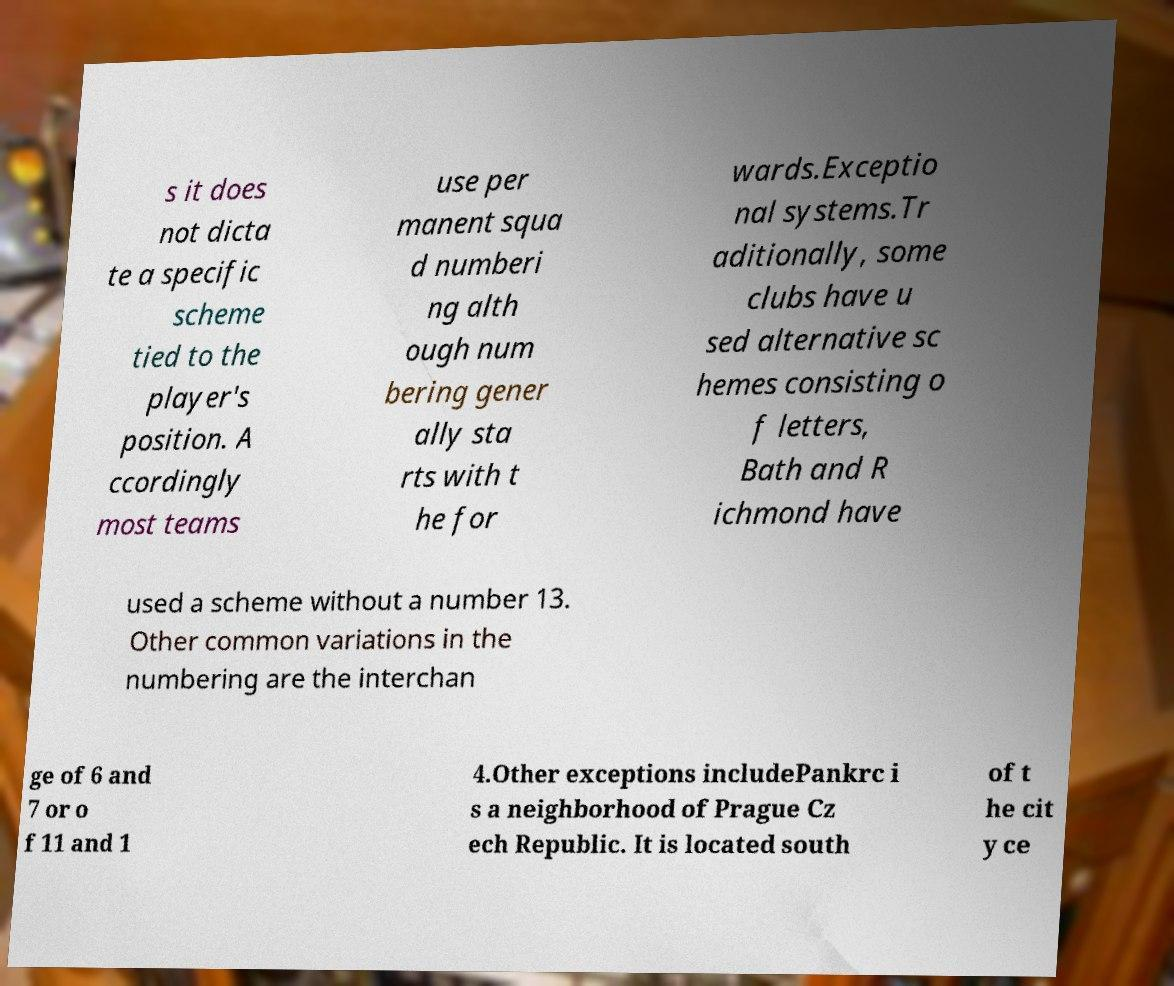What messages or text are displayed in this image? I need them in a readable, typed format. s it does not dicta te a specific scheme tied to the player's position. A ccordingly most teams use per manent squa d numberi ng alth ough num bering gener ally sta rts with t he for wards.Exceptio nal systems.Tr aditionally, some clubs have u sed alternative sc hemes consisting o f letters, Bath and R ichmond have used a scheme without a number 13. Other common variations in the numbering are the interchan ge of 6 and 7 or o f 11 and 1 4.Other exceptions includePankrc i s a neighborhood of Prague Cz ech Republic. It is located south of t he cit y ce 